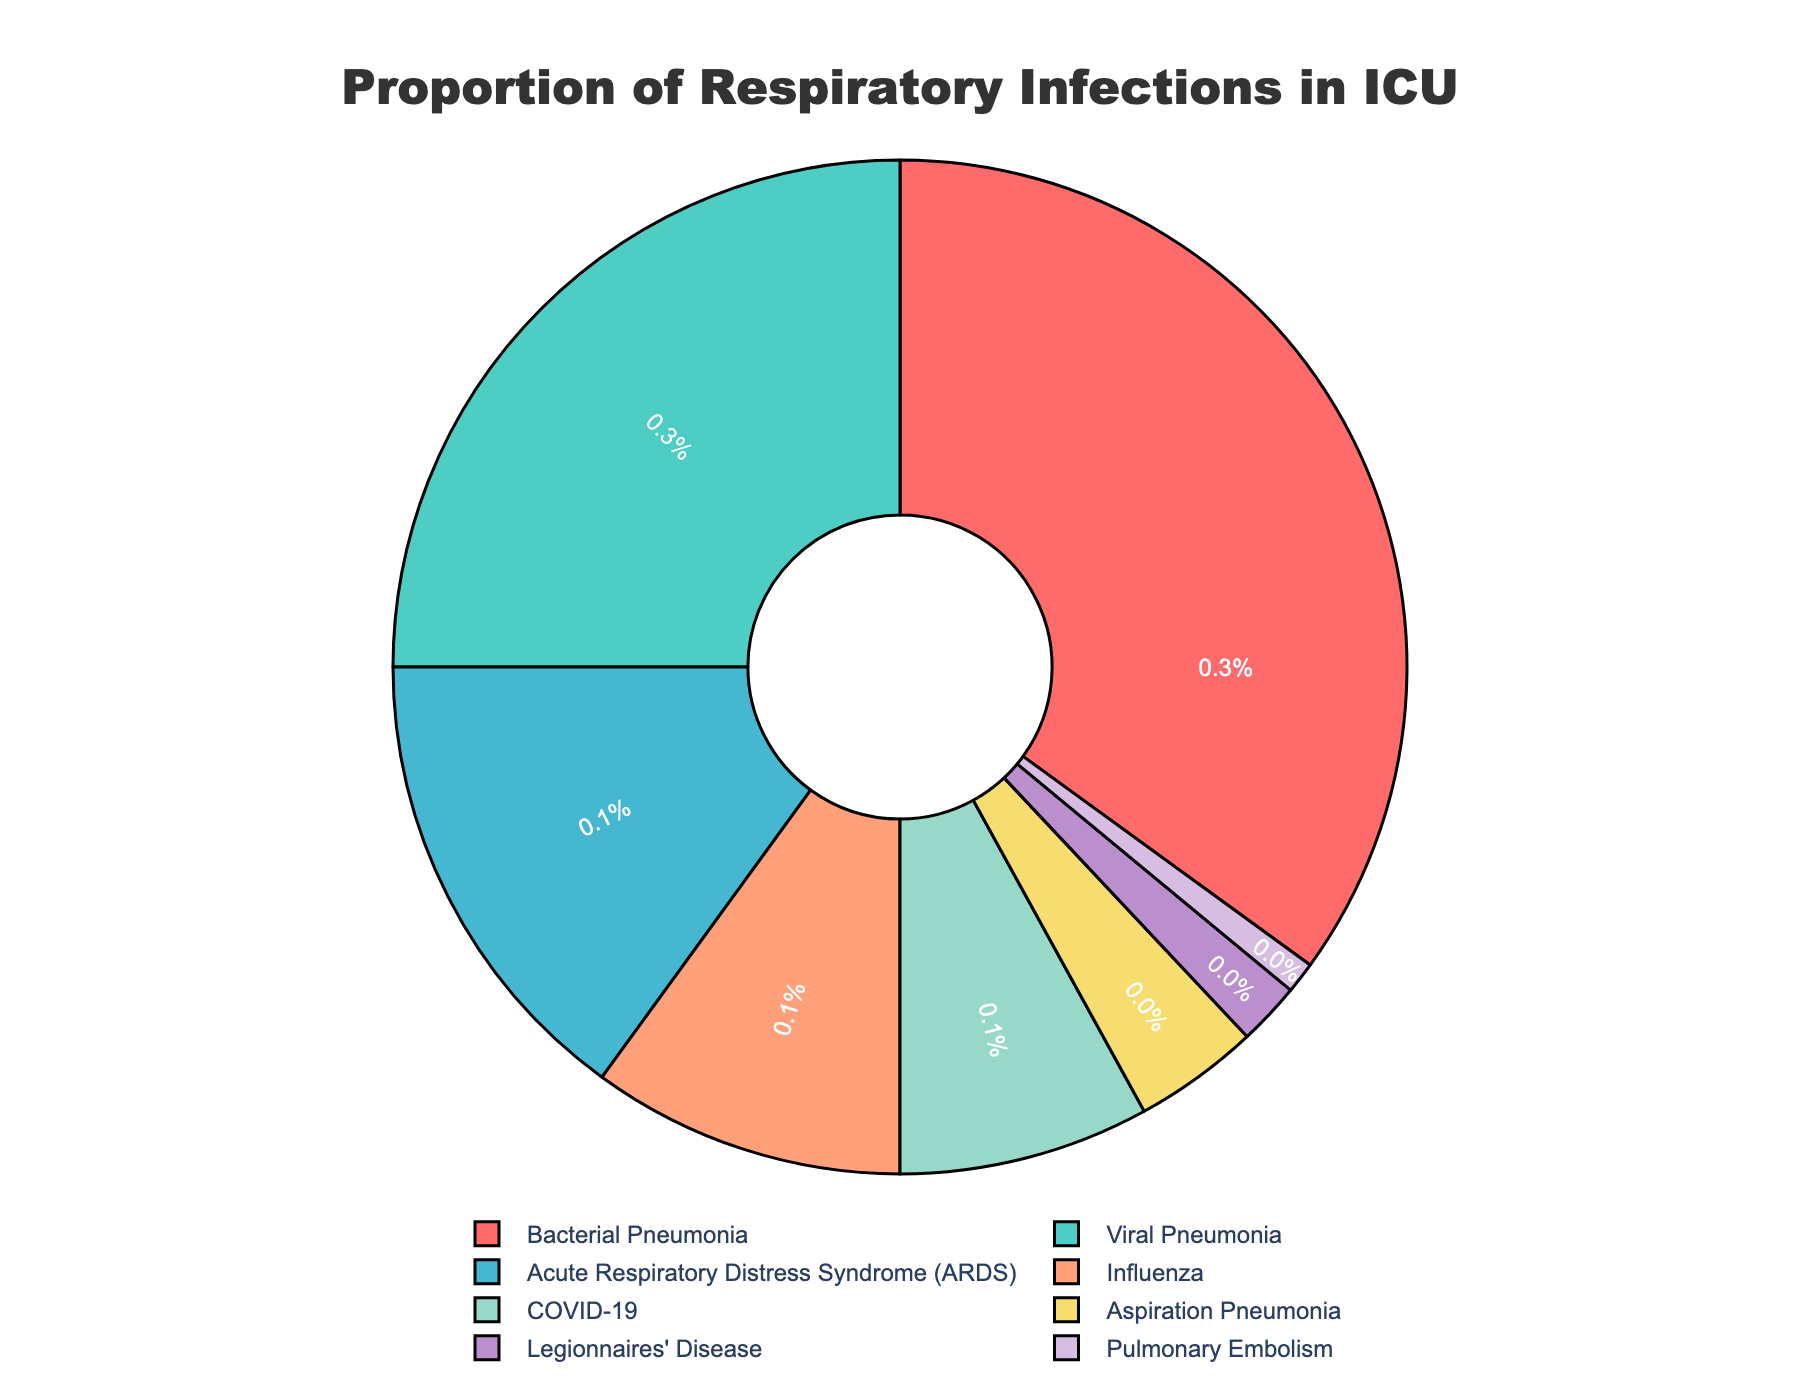What is the most common type of respiratory infection seen in the ICU? The largest slice in the pie chart represents Bacterial Pneumonia.
Answer: Bacterial Pneumonia What is the combined percentage of Viral Pneumonia and Influenza cases in the ICU? Viral Pneumonia accounts for 25% and Influenza accounts for 10%. Adding them together gives 25% + 10% = 35%.
Answer: 35% Which infection type has the smallest proportion, and what is its percentage? The smallest slice in the pie chart represents Pulmonary Embolism, with a percentage of 1%.
Answer: Pulmonary Embolism, 1% Are there more cases of COVID-19 or Influenza in the ICU? The pie chart shows that COVID-19 has 8% and Influenza has 10%. Since 10% is greater than 8%, there are more cases of Influenza.
Answer: Influenza How much larger is the proportion of Bacterial Pneumonia cases compared to ARDS (Acute Respiratory Distress Syndrome)? Bacterial Pneumonia accounts for 35%, ARDS for 15%. The difference is 35% - 15% = 20%.
Answer: 20% Which color represents the cases of Legionnaires' Disease on the pie chart? The slice representing Legionnaires' Disease is colored purple.
Answer: Purple What is the proportion of cases represented by the two least common respiratory infections combined? The least common are Pulmonary Embolism (1%) and Legionnaires' Disease (2%). Adding them together gives 1% + 2% = 3%.
Answer: 3% If you were to group all pneumonias (Bacterial, Viral, Aspiration) together, what would their combined percentage be? Bacterial Pneumonia (35%) + Viral Pneumonia (25%) + Aspiration Pneumonia (4%) = 64%.
Answer: 64% Is the proportion of COVID-19 cases greater than that of ARDS? COVID-19 accounts for 8%, while ARDS accounts for 15%. Since 15% is greater than 8%, ARDS has a higher percentage.
Answer: No What is the difference between the percentages of Bacterial Pneumonia and Viral Pneumonia? Bacterial Pneumonia has 35% and Viral Pneumonia has 25%. The difference is 35% - 25% = 10%.
Answer: 10% 